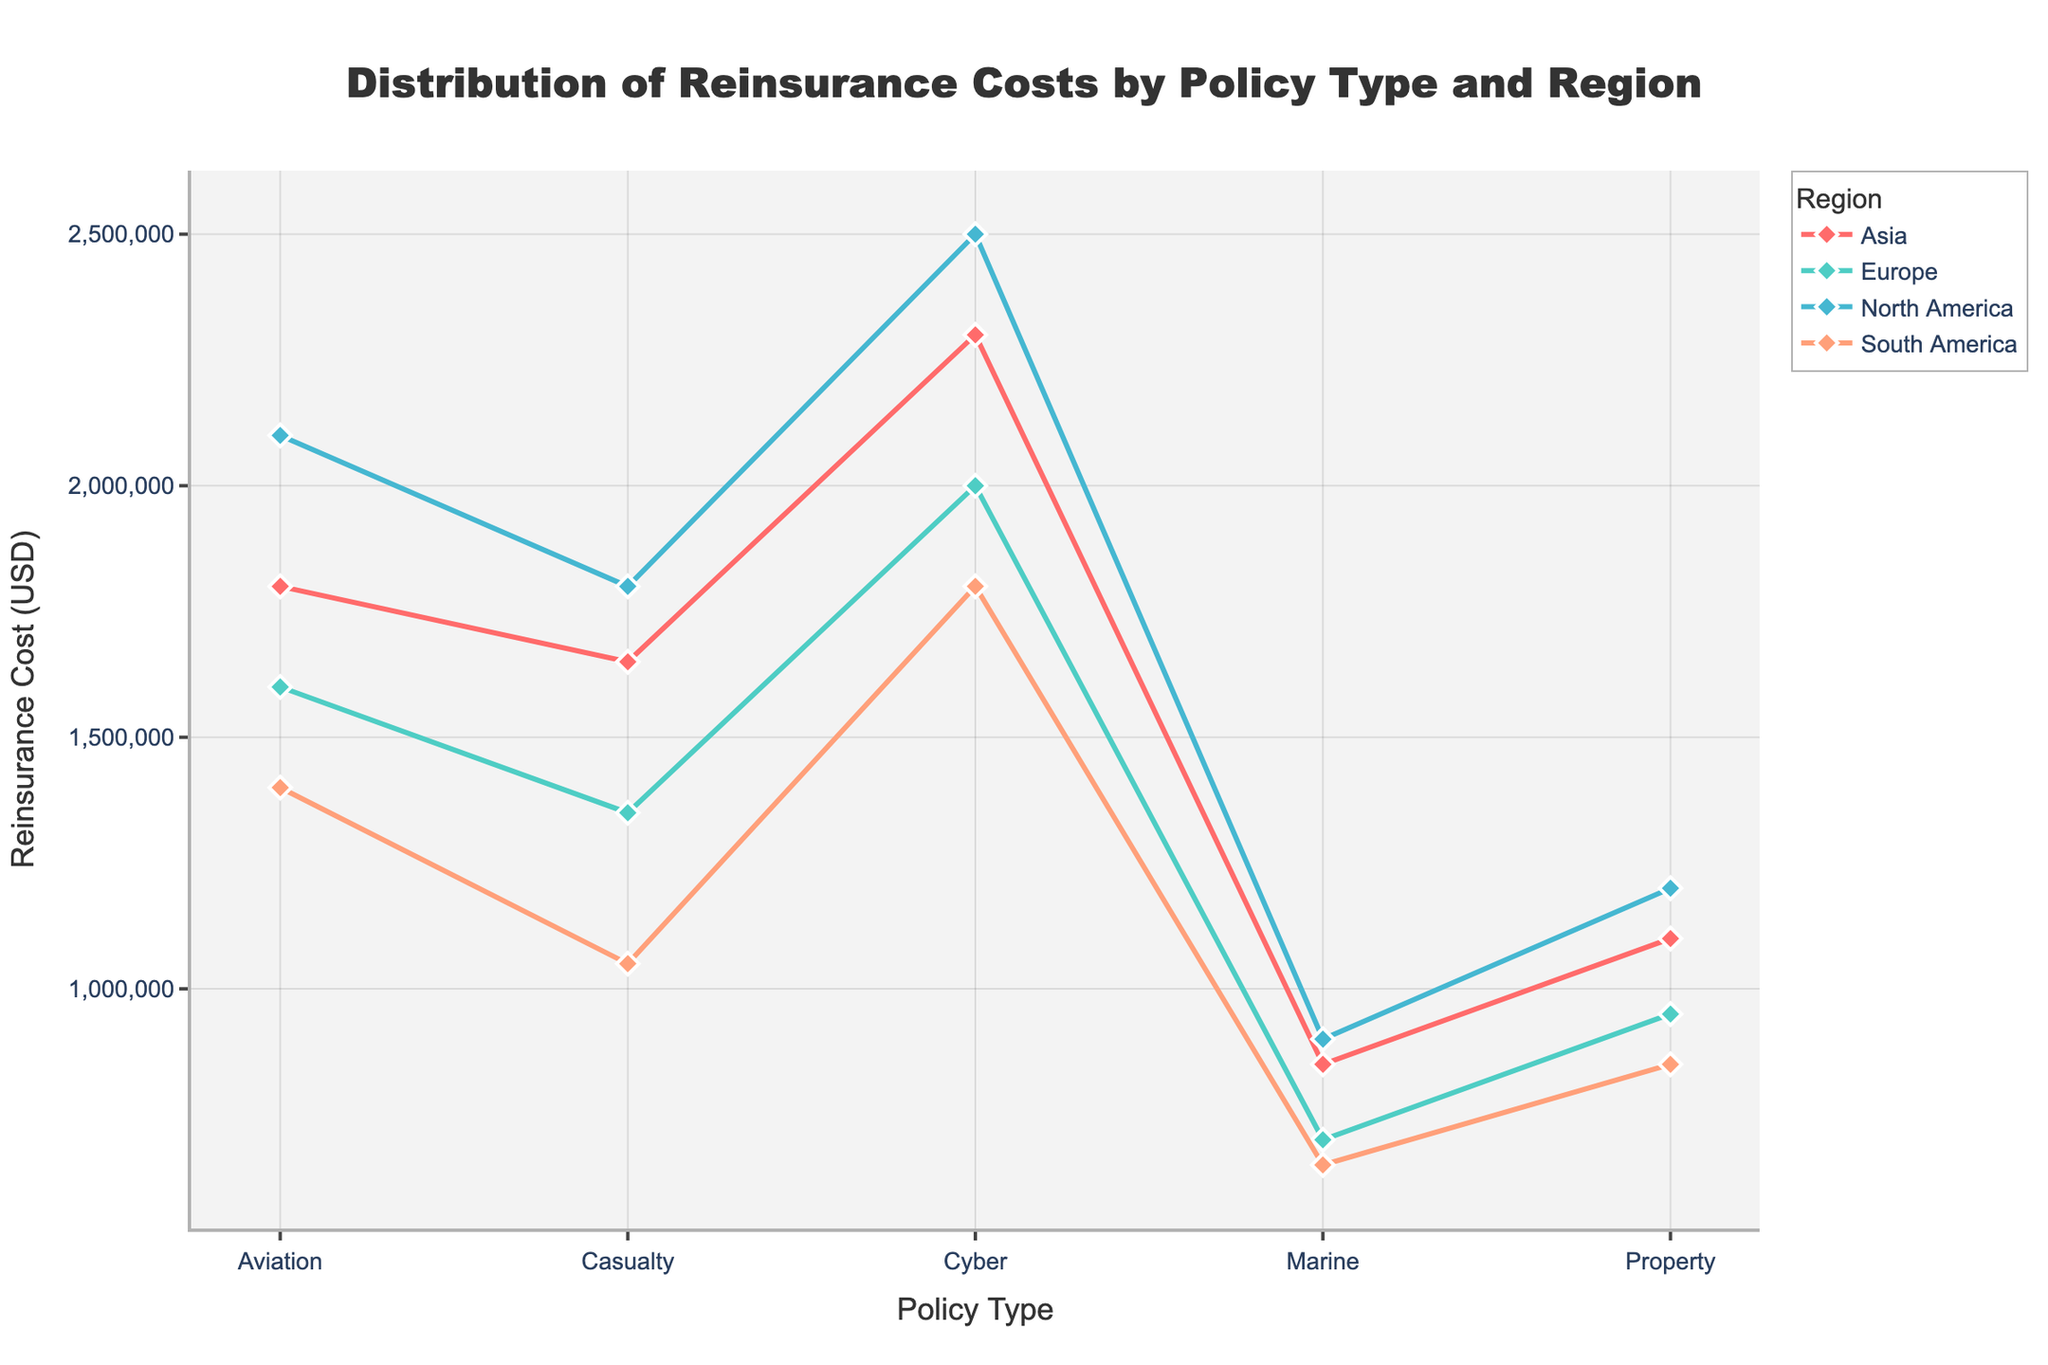What is the title of the figure? The title of the figure is typically located at the top of a plot, indicating the main topic or focus of the visual data representation. In this figure, the title is clearly displayed at the top.
Answer: Distribution of Reinsurance Costs by Policy Type and Region What is the highest reinsurance cost for the Casualty policy type? To find the highest reinsurance cost, look at the y-values for each region under the Casualty policy type and identify the maximum value. The regions are North America, Europe, Asia, and South America. The values are 1,800,000, 1,350,000, 1,650,000, and 1,050,000, respectively.
Answer: 1,800,000 Which policy type has the lowest reinsurance cost in Europe? Locate the Europe region line in the figure and examine the y-values for each policy type. The policy types are Property, Casualty, Marine, Aviation, and Cyber with costs of 950,000, 1,350,000, 700,000, 1,600,000, and 2,000,000, respectively. The lowest cost is for Marine.
Answer: Marine What is the overall trend for Cyber reinsurance costs across regions? Follow the Cyber policy type line across all regions (North America, Europe, Asia, and South America) and observe the y-values. The costs are 2,500,000, 2,000,000, 2,300,000, and 1,800,000, respectively. The costs decrease from North America to South America.
Answer: Decreasing Compare the reinsurance costs of Property and Marine policy types in Asia. Which one is higher? Identify the y-values for Property and Marine policy types in the Asia region. Property has a cost of 1,100,000, and Marine has a cost of 850,000. Compare these two values to determine which is higher.
Answer: Property How much greater is the reinsurance cost for Cyber policy in North America compared to South America? Identify the reinsurance costs for Cyber policy in North America (2,500,000) and in South America (1,800,000). Subtract the South America value from the North America value to find the difference: 2,500,000 - 1,800,000.
Answer: 700,000 Which policy type shows the least variation in reinsurance cost across all regions? To determine the least variation, examine the y-values for each policy type across all regions and calculate the range (highest value minus lowest value) for each policy type. Compare these ranges. Marine has values of 900,000, 700,000, 850,000, and 650,000. The difference between the highest and lowest values is 900,000 - 650,000. This shows the least variation.
Answer: Marine Which region has the highest overall reinsurance costs across all policy types? Sum up the reinsurance costs for all policy types within each region. Compare these totals to determine which region has the highest overall cost. For North America: 1,200,000 + 1,800,000 + 900,000 + 2,100,000 + 2,500,000 = 8,500,000. Repeat this for other regions and identify the highest value.
Answer: North America What is the median reinsurance cost for Aviation policy type across the regions? List the reinsurance costs for the Aviation policy type in all regions: 2,100,000, 1,600,000, 1,800,000, and 1,400,000. Arrange these values in ascending order: 1,400,000, 1,600,000, 1,800,000, 2,100,000. The median is the average of the two middle values: (1,600,000 + 1,800,000) / 2.
Answer: 1,700,000 